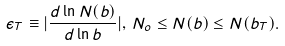<formula> <loc_0><loc_0><loc_500><loc_500>\epsilon _ { T } \equiv | \frac { d \ln N ( b ) } { d \ln b } | , \, N _ { o } \leq N ( b ) \leq N ( b _ { T } ) .</formula> 